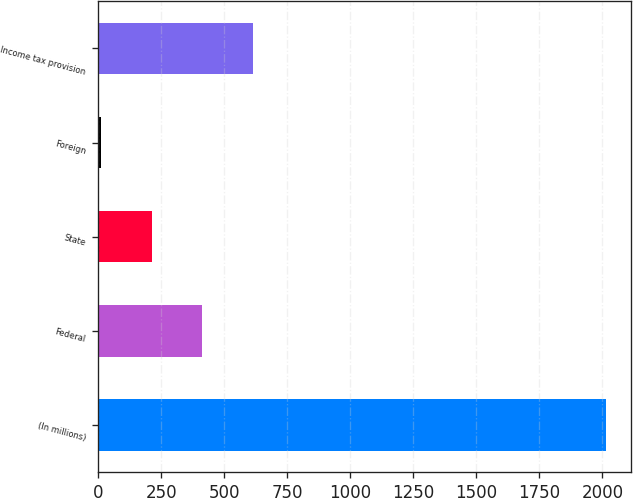Convert chart. <chart><loc_0><loc_0><loc_500><loc_500><bar_chart><fcel>(In millions)<fcel>Federal<fcel>State<fcel>Foreign<fcel>Income tax provision<nl><fcel>2013<fcel>412.2<fcel>212.1<fcel>12<fcel>612.3<nl></chart> 